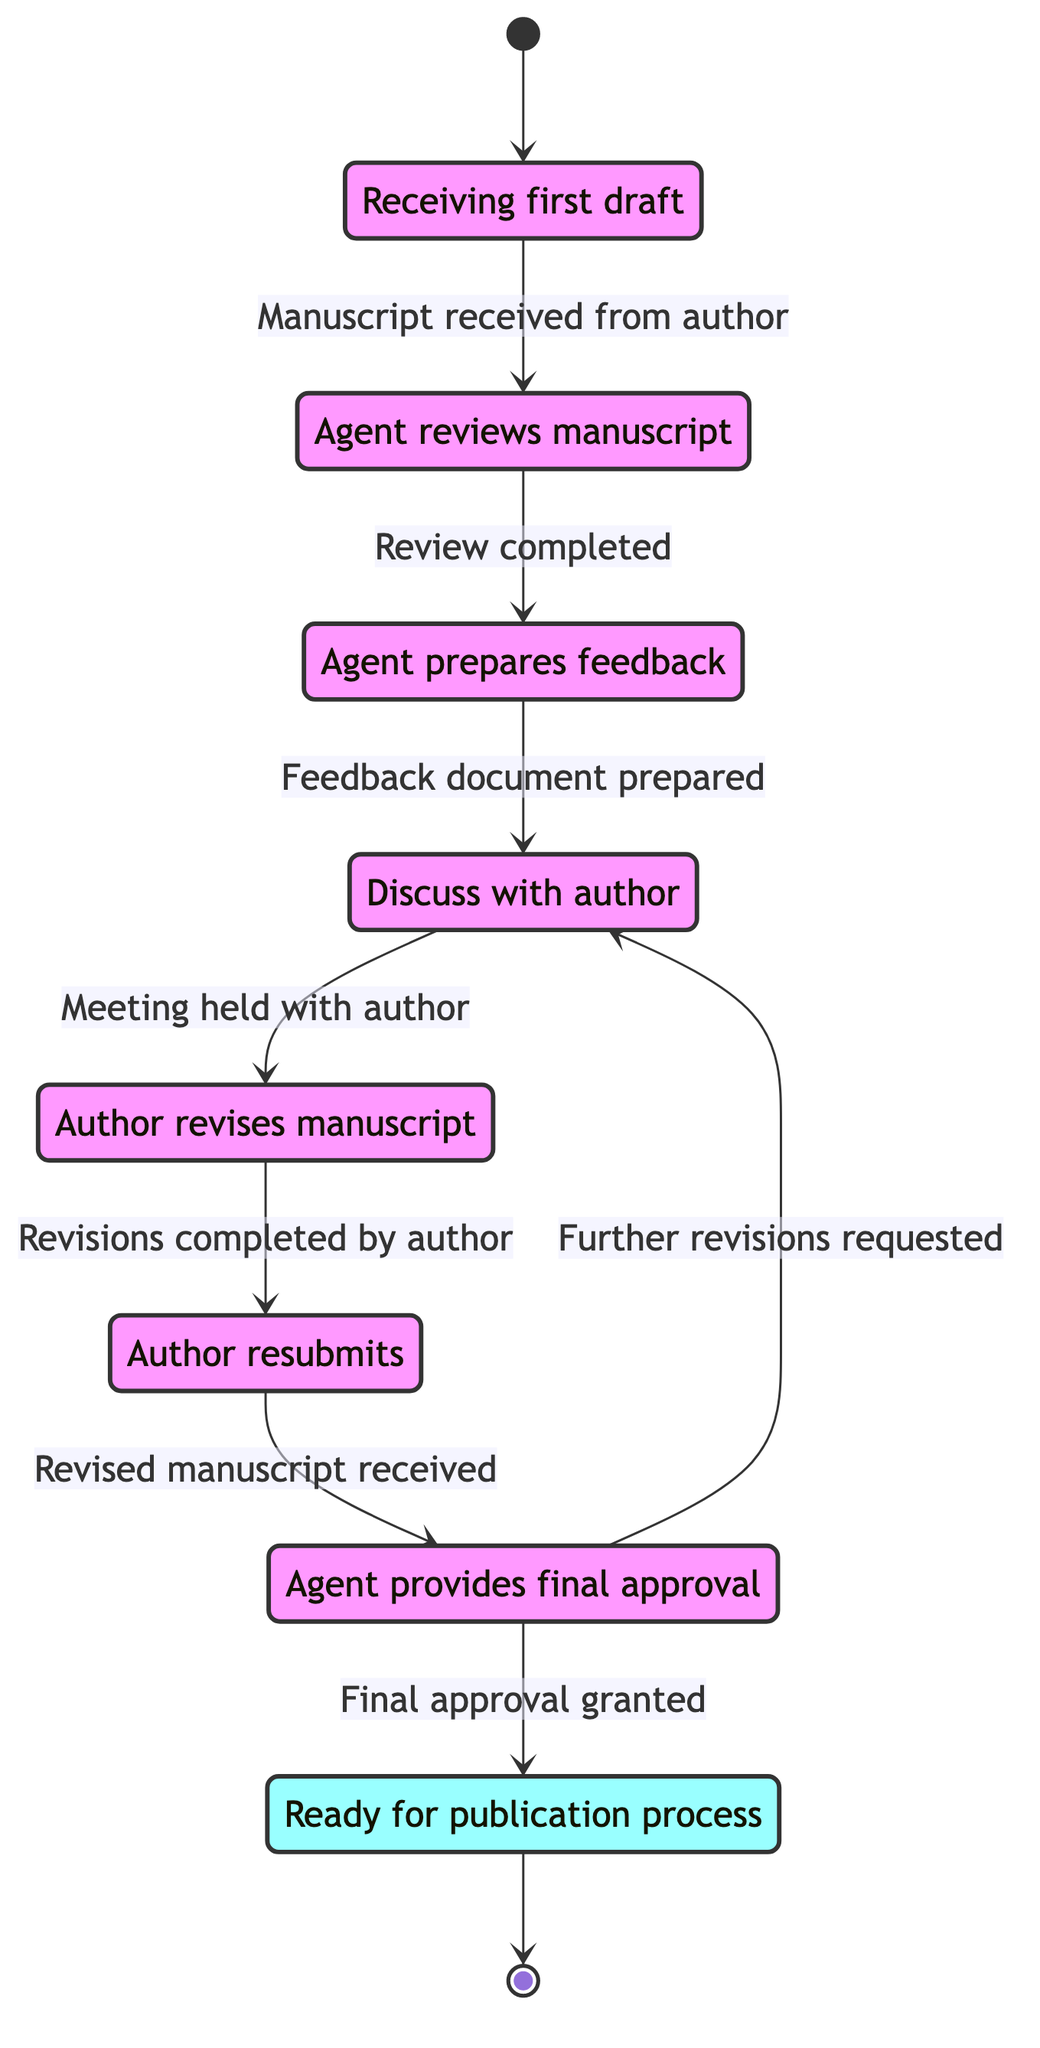What is the starting state of the feedback cycle? The diagram indicates the starting point is "Initial_Manuscript_Received," which is the first state reached before any transitions occur in the process.
Answer: Initial Manuscript Received How many states are present in the diagram? By counting each unique state listed in the diagram, there are eight different states, showing the various stages the manuscript goes through.
Answer: Eight What is the condition for moving from Manuscript Review to Feedback Preparation? The transition from Manuscript Review to Feedback Preparation is based on the condition that the "Review completed," showing that the review process must be finalized before preparing feedback.
Answer: Review completed What happens after the agent discusses feedback with the author? After the "Feedback Discussion" state, the process moves to "Revisions by Author," indicating that meeting and discussing feedback prompts the author to begin making revisions.
Answer: Revisions by Author What transition occurs if further revisions are requested after the final manuscript approval? The transition following "Final Manuscript Approval" to a state where further changes are necessary leads back to "Feedback Discussion," indicating further steps taken for adjustments.
Answer: Feedback Discussion How does the process end in this feedback cycle? The cycle concludes at the "Ready for Publication" state, which is designated as the final state where the manuscript is fully prepared for publication after receiving final approval.
Answer: Ready for Publication Which state follows the resubmission of a revised manuscript? The state that immediately follows the "Revised Manuscript Resubmitted" is "Final Manuscript Approval," signifying that the agent's review of the changes made is a subsequent step.
Answer: Final Manuscript Approval What is the last step before the manuscript can be published? Before the publication process can initiate, the "Final Manuscript Approval" must be achieved, indicating the manuscript must be approved to proceed to the final preparations for publication.
Answer: Final Manuscript Approval 